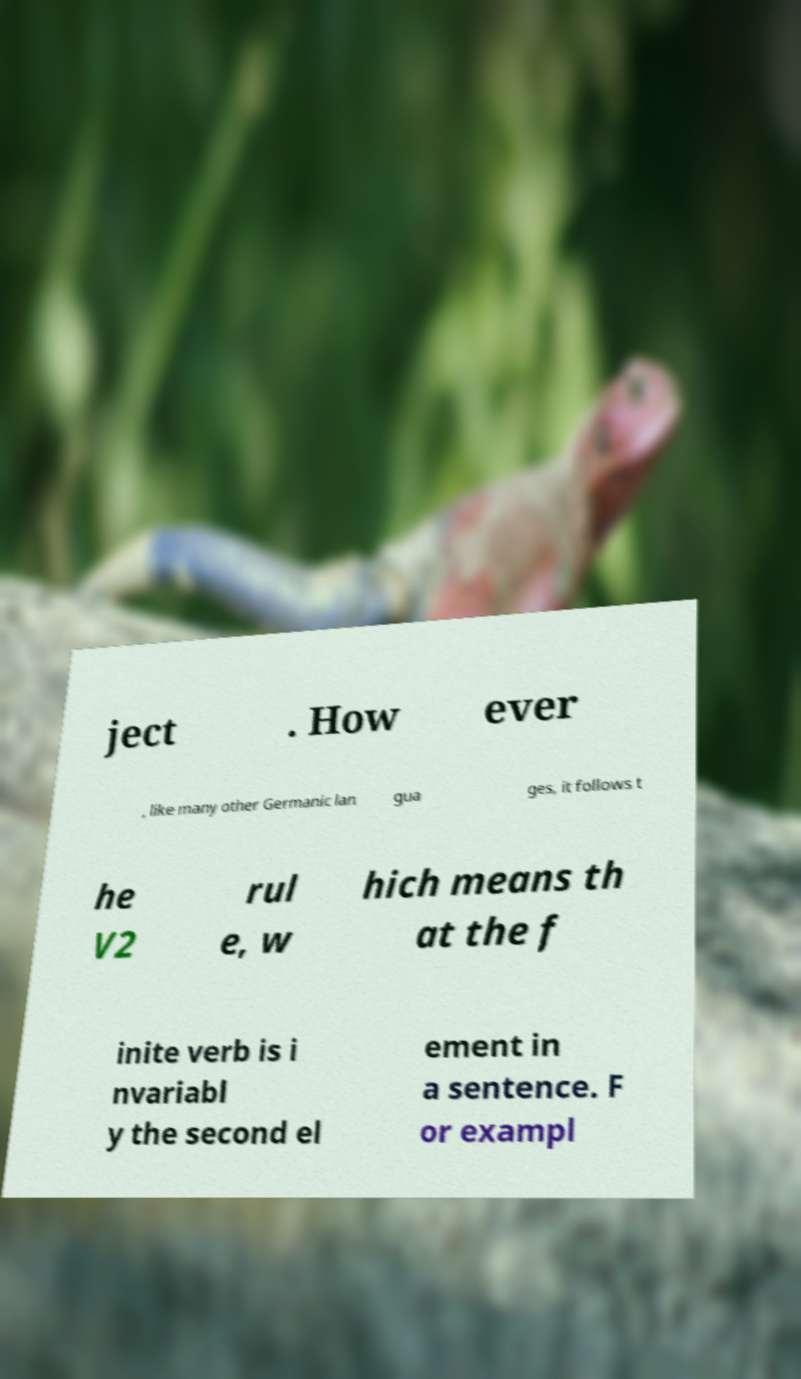I need the written content from this picture converted into text. Can you do that? ject . How ever , like many other Germanic lan gua ges, it follows t he V2 rul e, w hich means th at the f inite verb is i nvariabl y the second el ement in a sentence. F or exampl 